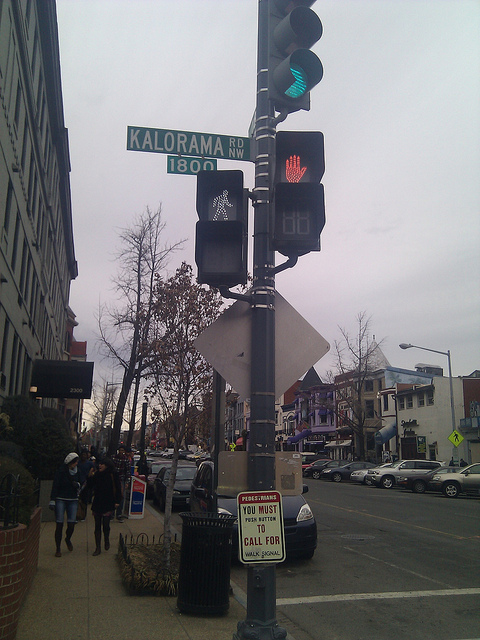Read and extract the text from this image. KALORAMA RD 1800 YOU MUST 90 CALL FOR WALLER 